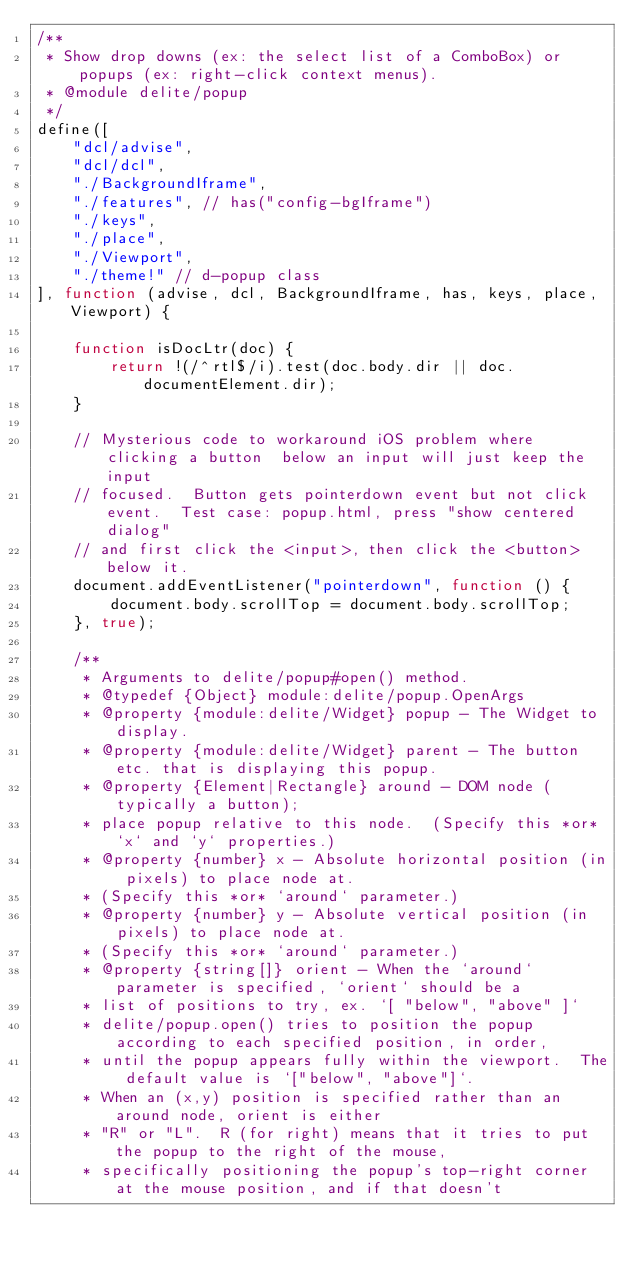Convert code to text. <code><loc_0><loc_0><loc_500><loc_500><_JavaScript_>/**
 * Show drop downs (ex: the select list of a ComboBox) or popups (ex: right-click context menus).
 * @module delite/popup
 */
define([
	"dcl/advise",
	"dcl/dcl",
	"./BackgroundIframe",
	"./features", // has("config-bgIframe")
	"./keys",
	"./place",
	"./Viewport",
	"./theme!" // d-popup class
], function (advise, dcl, BackgroundIframe, has, keys, place, Viewport) {

	function isDocLtr(doc) {
		return !(/^rtl$/i).test(doc.body.dir || doc.documentElement.dir);
	}

	// Mysterious code to workaround iOS problem where clicking a button  below an input will just keep the input
	// focused.  Button gets pointerdown event but not click event.  Test case: popup.html, press "show centered dialog"
	// and first click the <input>, then click the <button> below it.
	document.addEventListener("pointerdown", function () {
		document.body.scrollTop = document.body.scrollTop;
	}, true);

	/**
	 * Arguments to delite/popup#open() method.
	 * @typedef {Object} module:delite/popup.OpenArgs
	 * @property {module:delite/Widget} popup - The Widget to display.
	 * @property {module:delite/Widget} parent - The button etc. that is displaying this popup.
	 * @property {Element|Rectangle} around - DOM node (typically a button);
	 * place popup relative to this node.  (Specify this *or* `x` and `y` properties.)
	 * @property {number} x - Absolute horizontal position (in pixels) to place node at.
	 * (Specify this *or* `around` parameter.)
	 * @property {number} y - Absolute vertical position (in pixels) to place node at.
	 * (Specify this *or* `around` parameter.)
	 * @property {string[]} orient - When the `around` parameter is specified, `orient` should be a
	 * list of positions to try, ex. `[ "below", "above" ]`
	 * delite/popup.open() tries to position the popup according to each specified position, in order,
	 * until the popup appears fully within the viewport.  The default value is `["below", "above"]`.
	 * When an (x,y) position is specified rather than an around node, orient is either
	 * "R" or "L".  R (for right) means that it tries to put the popup to the right of the mouse,
	 * specifically positioning the popup's top-right corner at the mouse position, and if that doesn't</code> 